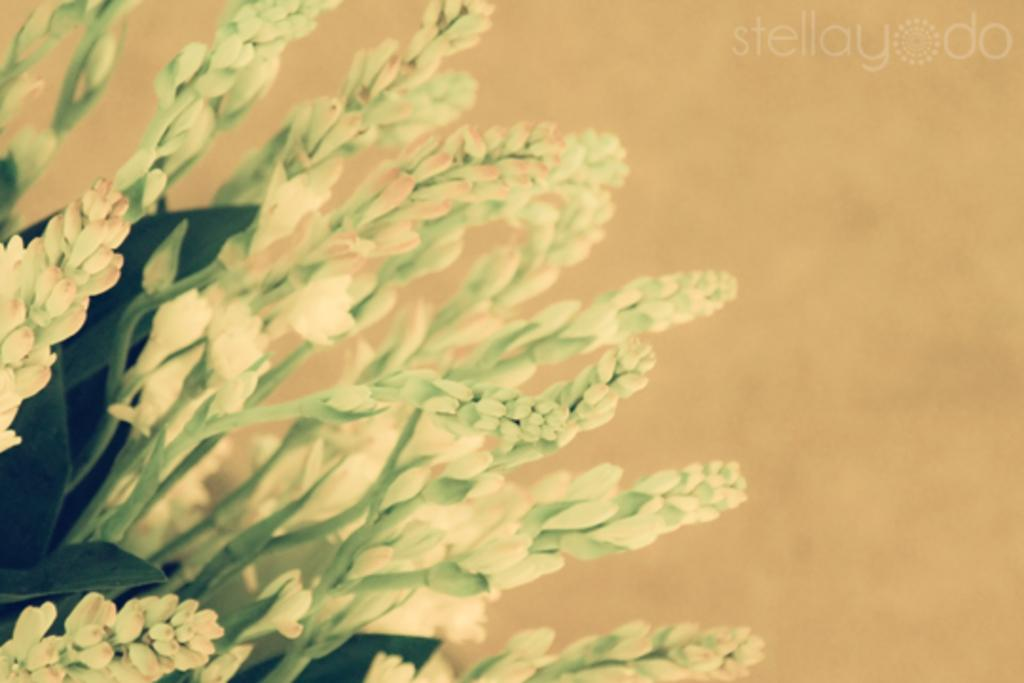What type of vegetation can be seen on the left side of the image? There are flowers on the left side of the image. What is located in the top right corner of the image? There is text in the top right corner of the image. How would you describe the color of the background in the image? The background of the image has a light golden color. What type of hobbies can be seen being practiced by the flowers in the image? There are no hobbies being practiced by the flowers in the image, as flowers are not capable of engaging in hobbies. Can you see a spade being used in the image? There is no spade present in the image. 